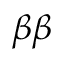<formula> <loc_0><loc_0><loc_500><loc_500>\beta \beta</formula> 